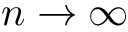Convert formula to latex. <formula><loc_0><loc_0><loc_500><loc_500>n \to \infty</formula> 